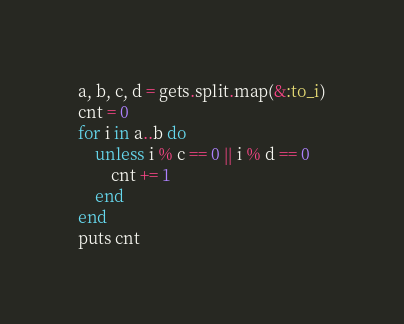<code> <loc_0><loc_0><loc_500><loc_500><_Ruby_>a, b, c, d = gets.split.map(&:to_i)
cnt = 0
for i in a..b do
    unless i % c == 0 || i % d == 0
        cnt += 1
    end
end
puts cnt</code> 